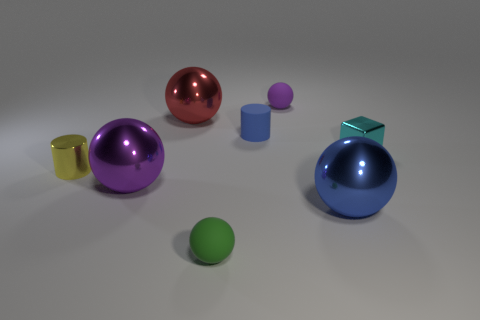Subtract all tiny rubber balls. How many balls are left? 3 Subtract all blue spheres. How many spheres are left? 4 Add 2 large shiny cylinders. How many objects exist? 10 Subtract all green spheres. Subtract all red cylinders. How many spheres are left? 4 Subtract all balls. How many objects are left? 3 Add 6 large blue metallic balls. How many large blue metallic balls exist? 7 Subtract 0 gray blocks. How many objects are left? 8 Subtract all yellow metal blocks. Subtract all rubber balls. How many objects are left? 6 Add 3 cyan shiny blocks. How many cyan shiny blocks are left? 4 